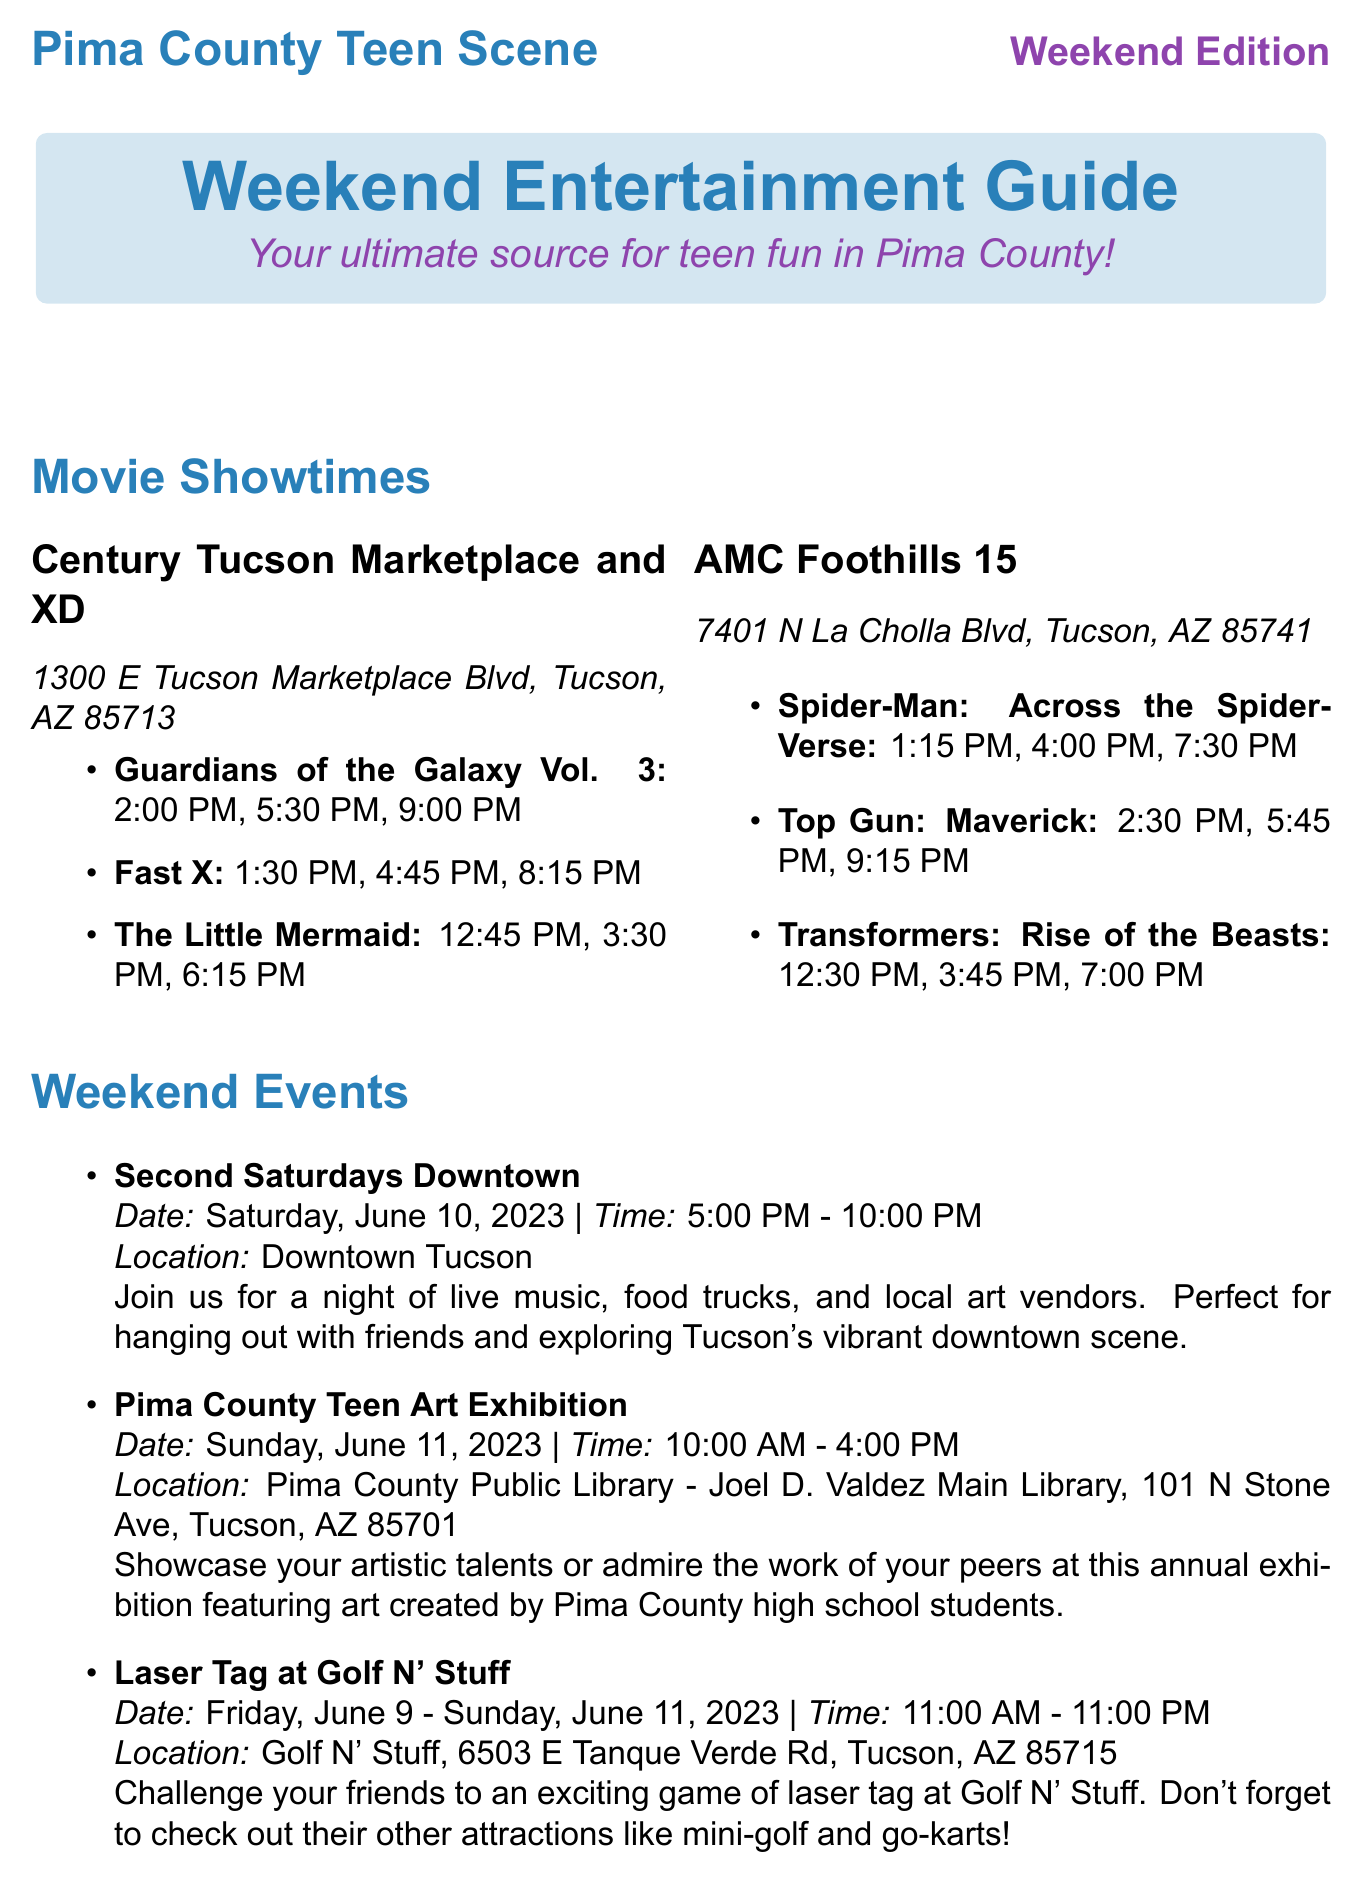What are the showtimes for "Guardians of the Galaxy Vol. 3"? The showtimes for "Guardians of the Galaxy Vol. 3" are 2:00 PM, 5:30 PM, and 9:00 PM.
Answer: 2:00 PM, 5:30 PM, 9:00 PM What is the address of AMC Foothills 15? The address for AMC Foothills 15 is 7401 N La Cholla Blvd, Tucson, AZ 85741.
Answer: 7401 N La Cholla Blvd, Tucson, AZ 85741 When is the Pima County Teen Art Exhibition? The Pima County Teen Art Exhibition is on Sunday, June 11, 2023.
Answer: Sunday, June 11, 2023 What time does the Laser Tag event start? The Laser Tag event starts at 11:00 AM.
Answer: 11:00 AM How much do tickets cost for the Reid Park Zoo Night Walk? Tickets for the Reid Park Zoo Night Walk cost $20 for teens (13-17).
Answer: $20 for teens (13-17) What is happening during the Second Saturdays Downtown? Second Saturdays Downtown features live music, food trucks, and local art vendors.
Answer: Live music, food trucks, and local art vendors What is a recommended activity for beginners at Sabino Canyon? A recommended activity for beginners at Sabino Canyon is hiking the Phoneline Trail.
Answer: Hiking the Phoneline Trail What is the cuisine type of Eegee's? The cuisine type of Eegee's is Fast Food, Sandwiches.
Answer: Fast Food, Sandwiches 